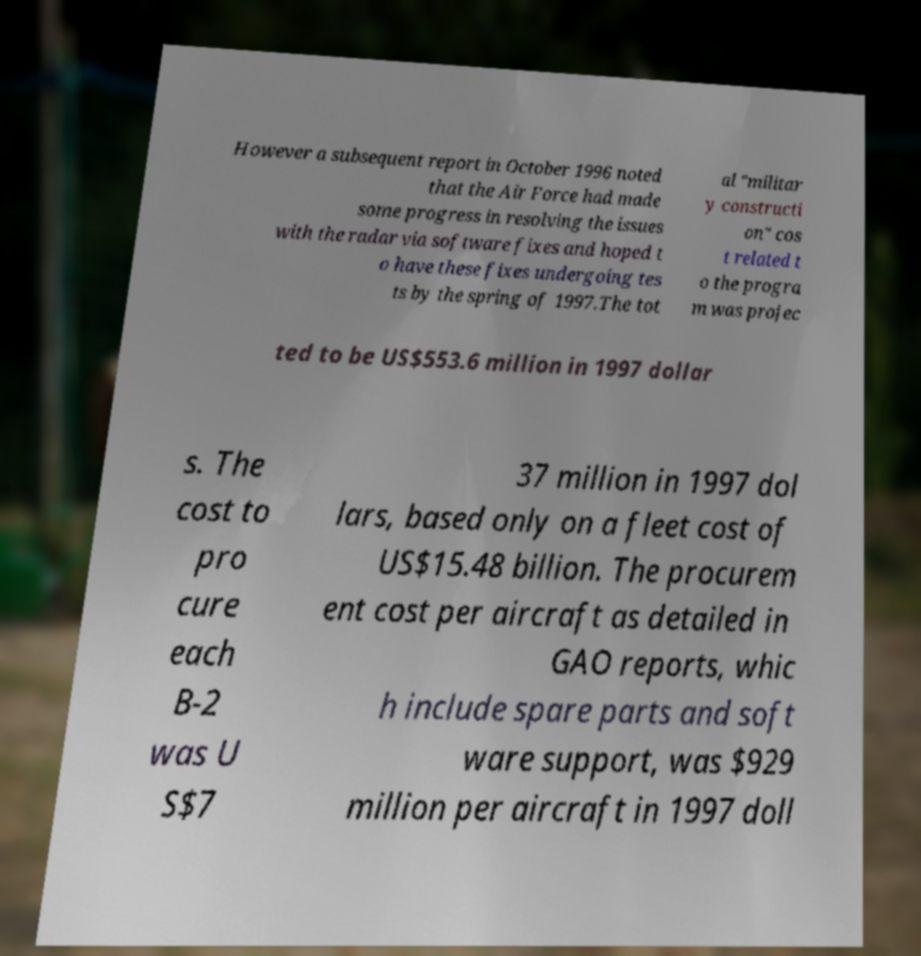What messages or text are displayed in this image? I need them in a readable, typed format. However a subsequent report in October 1996 noted that the Air Force had made some progress in resolving the issues with the radar via software fixes and hoped t o have these fixes undergoing tes ts by the spring of 1997.The tot al "militar y constructi on" cos t related t o the progra m was projec ted to be US$553.6 million in 1997 dollar s. The cost to pro cure each B-2 was U S$7 37 million in 1997 dol lars, based only on a fleet cost of US$15.48 billion. The procurem ent cost per aircraft as detailed in GAO reports, whic h include spare parts and soft ware support, was $929 million per aircraft in 1997 doll 